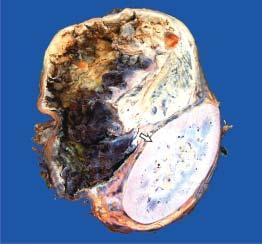what shows a large spherical tumour separate from the kidney?
Answer the question using a single word or phrase. Upper end 